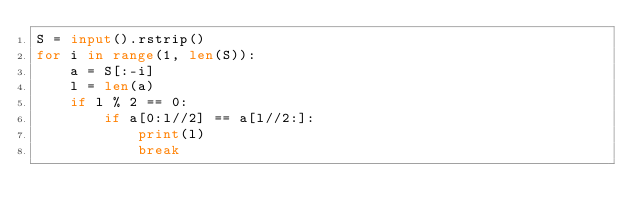<code> <loc_0><loc_0><loc_500><loc_500><_Python_>S = input().rstrip()
for i in range(1, len(S)):
    a = S[:-i]
    l = len(a)
    if l % 2 == 0:
        if a[0:l//2] == a[l//2:]:
            print(l)
            break</code> 